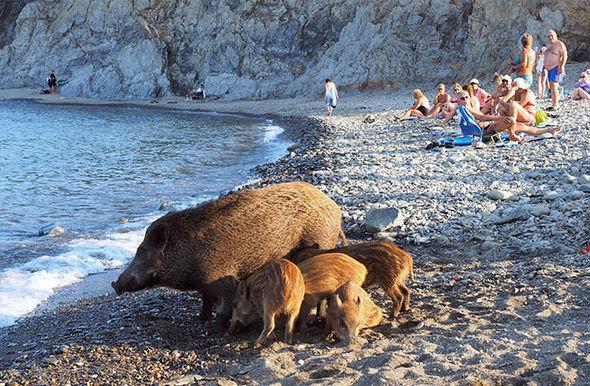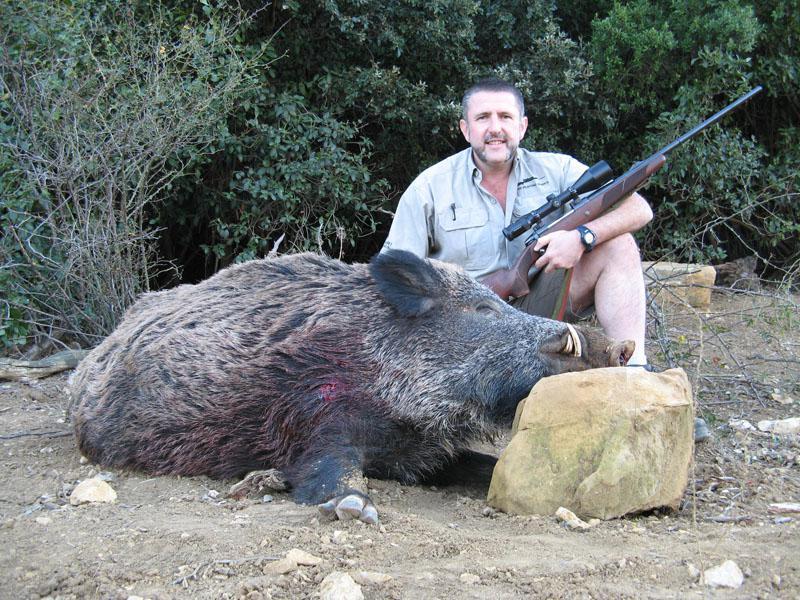The first image is the image on the left, the second image is the image on the right. Given the left and right images, does the statement "An image includes at least three striped baby pigs next to a standing adult wild hog." hold true? Answer yes or no. Yes. The first image is the image on the left, the second image is the image on the right. Examine the images to the left and right. Is the description "The left image contains at least four boars." accurate? Answer yes or no. Yes. 